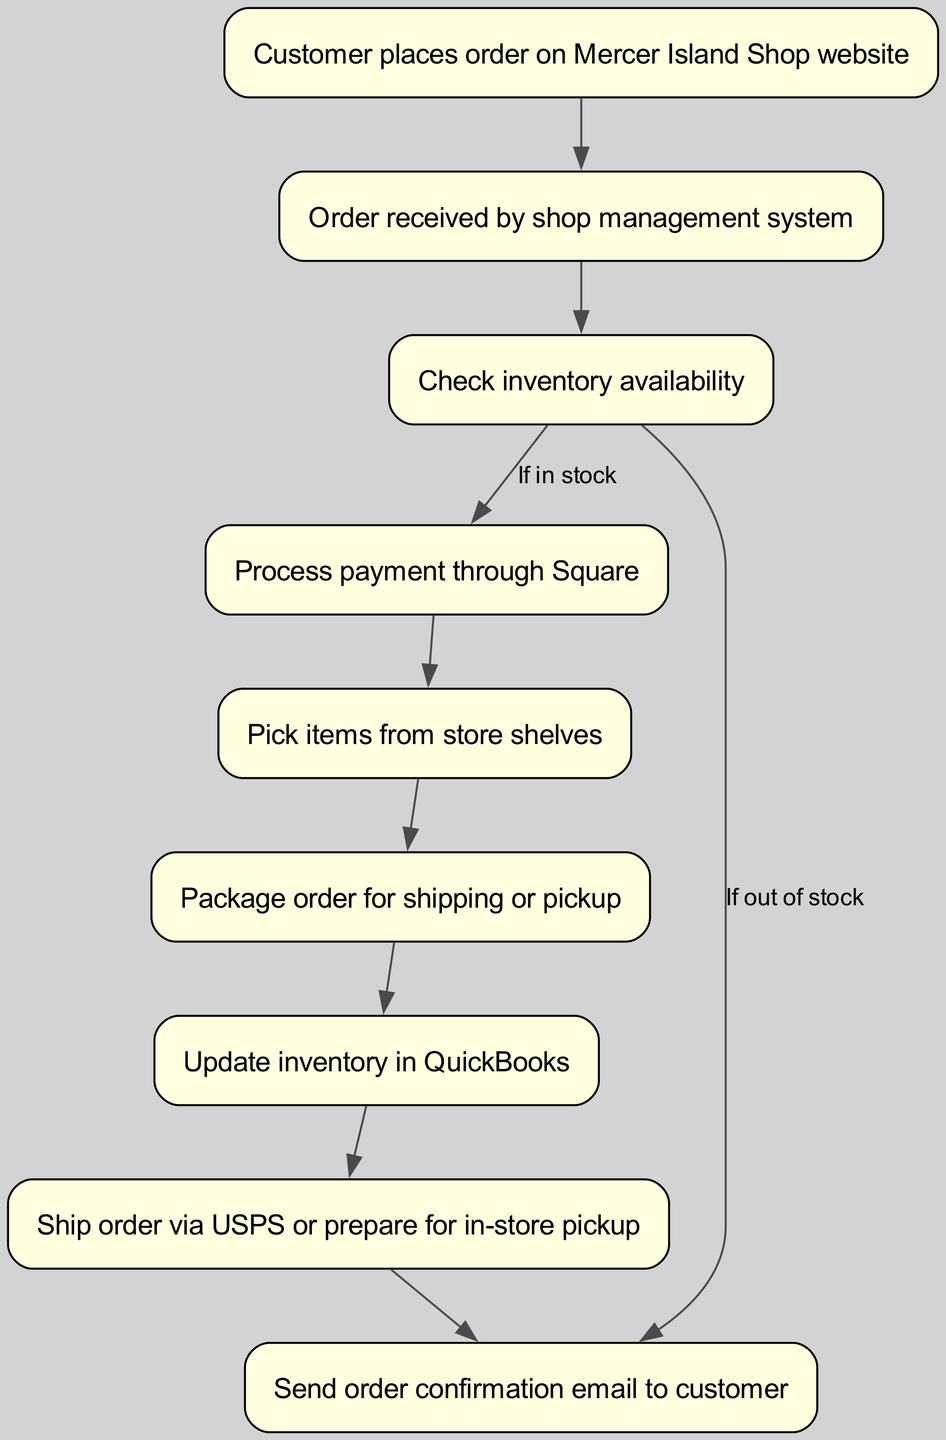What is the first step when a customer places an order? The diagram indicates that the first step occurs when the customer places an order on the Mercer Island Shop website. This is represented as the starting node.
Answer: Customer places order on Mercer Island Shop website What does the shop management system do after receiving an order? According to the flowchart, once the order is received by the shop management system, the next step is to check inventory availability.
Answer: Check inventory availability How many nodes are present in the flowchart? The flowchart specifies several nodes, and counting them reveals a total of nine distinct steps involved in the order processing and fulfillment.
Answer: 9 What happens if inventory is not available? The flowchart illustrates that, in the case of insufficient stock, the process diverts directly to sending an order confirmation email to the customer, bypassing the payment and fulfillment steps.
Answer: Send order confirmation email to customer What is the final step in the order process? The flowchart concludes with the last action of sending an order confirmation email to the customer, which is the endpoint of the process.
Answer: Send order confirmation email to customer If the items are in stock, which action follows after processing payment? Based on the diagram, if items are confirmed to be in stock, the subsequent action that follows the processing of payment is picking items from store shelves.
Answer: Pick items from store shelves What is the second node in the flowchart? The diagram outlines the order of operations, with 'Order received by shop management system' being the second node that follows the initial action of placing an order.
Answer: Order received by shop management system Which payment system is used to process payments? The flowchart explicitly states that payments are processed through Square, showing the specific payment system utilized in the order fulfillment process.
Answer: Square What action is taken after packaging the order? Following the packaging of the order, the flowchart indicates that the next step involves updating the inventory in QuickBooks.
Answer: Update inventory in QuickBooks 